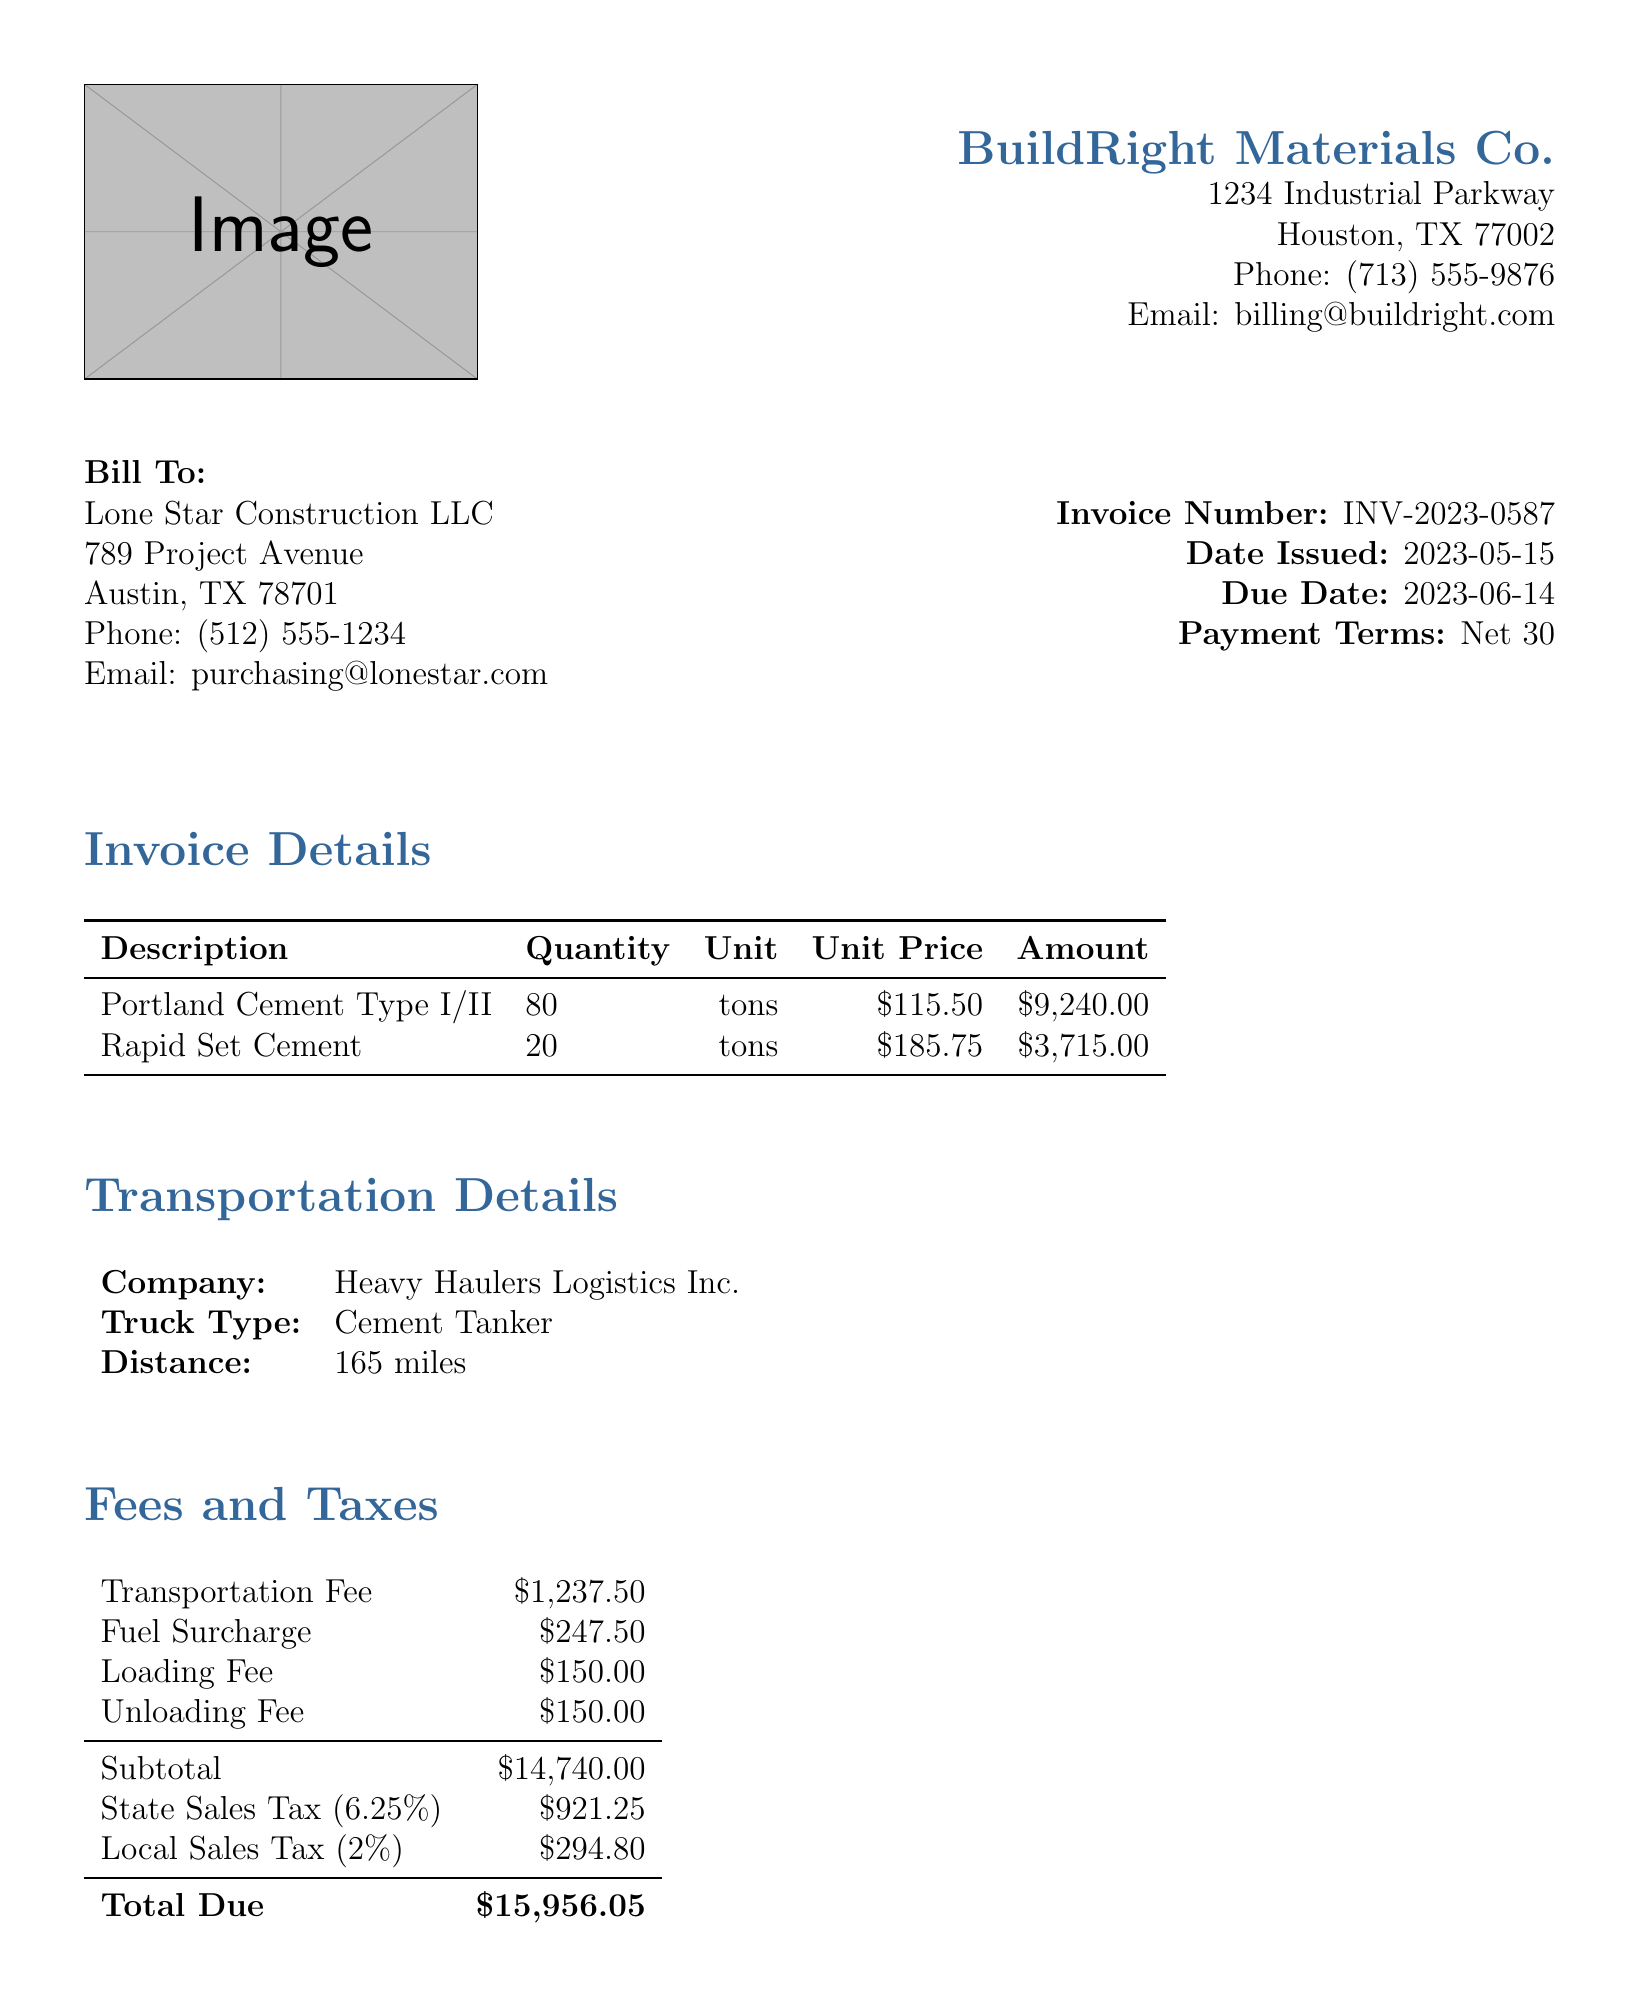what is the invoice number? The invoice number is specifically listed on the document for identification purposes.
Answer: INV-2023-0587 what is the due date for this invoice? The due date indicates when payment is expected; it is provided in the document.
Answer: 2023-06-14 how many tons of Portland Cement Type I/II were delivered? The quantity of each delivered item is specified in the invoice under the itemized list.
Answer: 80 what is the total amount due? The total amount due is typically found at the end sections of the invoice, summarizing all charges, fees, and taxes.
Answer: 15956.05 what is the transportation fee? Fees are detailed separately, and the transportation fee is explicitly mentioned.
Answer: 1237.50 who is the logistics company responsible for transportation? The company responsible for transportation is listed in the transportation details section of the invoice.
Answer: Heavy Haulers Logistics Inc what is the local sales tax percentage applied? The invoice specifies the percentages of applicable taxes in the fees section.
Answer: 2% how much was charged for the unloading fee? The unloading fee is listed among the various fees applicable to this transaction.
Answer: 150.00 what are the payment terms specified in the invoice? Payment terms indicate the timelines for payment, detailed early in the invoice.
Answer: Net 30 